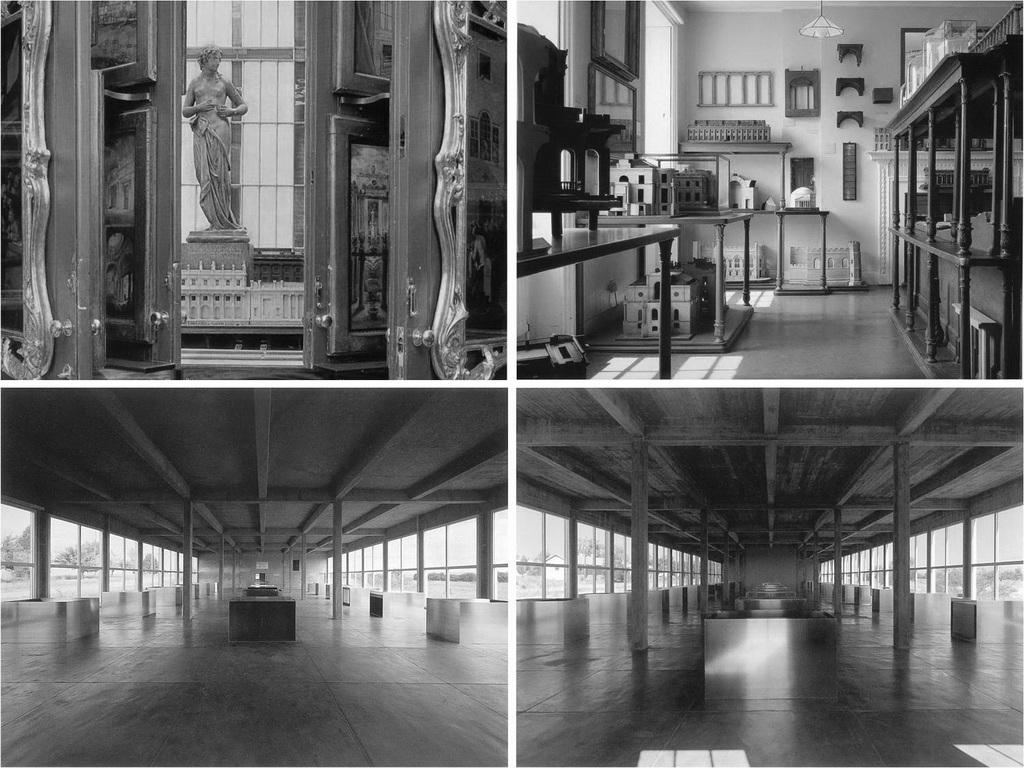What is the main subject in the center of the image? There is a collage in the center of the image. What can be observed within the collage? The collage includes different pictures. What type of yarn is used to create the town in the image? There is no town or yarn present in the image; it features a collage with different pictures. 